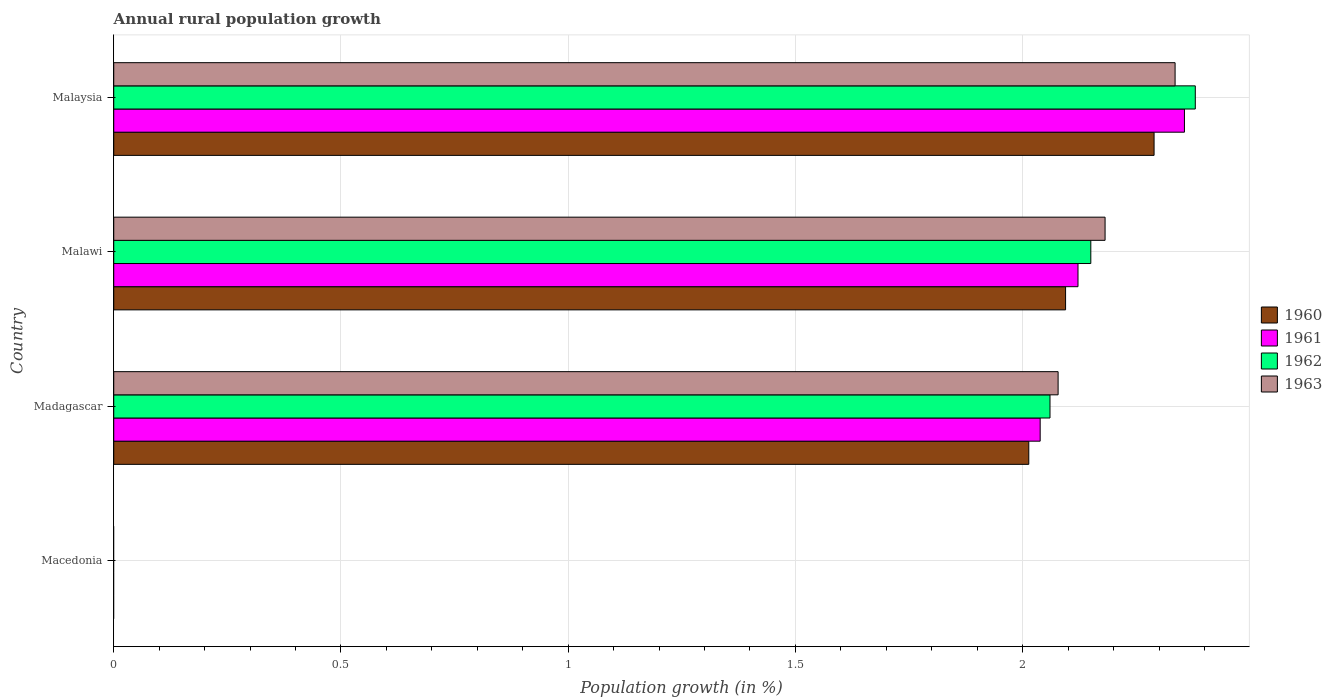How many different coloured bars are there?
Ensure brevity in your answer.  4. What is the label of the 4th group of bars from the top?
Make the answer very short. Macedonia. What is the percentage of rural population growth in 1961 in Malawi?
Your response must be concise. 2.12. Across all countries, what is the maximum percentage of rural population growth in 1960?
Offer a terse response. 2.29. Across all countries, what is the minimum percentage of rural population growth in 1962?
Your answer should be very brief. 0. In which country was the percentage of rural population growth in 1963 maximum?
Offer a very short reply. Malaysia. What is the total percentage of rural population growth in 1962 in the graph?
Keep it short and to the point. 6.59. What is the difference between the percentage of rural population growth in 1962 in Malawi and that in Malaysia?
Offer a very short reply. -0.23. What is the difference between the percentage of rural population growth in 1963 in Malaysia and the percentage of rural population growth in 1962 in Madagascar?
Your answer should be very brief. 0.28. What is the average percentage of rural population growth in 1960 per country?
Ensure brevity in your answer.  1.6. What is the difference between the percentage of rural population growth in 1961 and percentage of rural population growth in 1960 in Malawi?
Your response must be concise. 0.03. In how many countries, is the percentage of rural population growth in 1962 greater than 0.8 %?
Offer a terse response. 3. What is the ratio of the percentage of rural population growth in 1962 in Malawi to that in Malaysia?
Keep it short and to the point. 0.9. What is the difference between the highest and the second highest percentage of rural population growth in 1963?
Provide a short and direct response. 0.15. What is the difference between the highest and the lowest percentage of rural population growth in 1962?
Keep it short and to the point. 2.38. In how many countries, is the percentage of rural population growth in 1962 greater than the average percentage of rural population growth in 1962 taken over all countries?
Provide a succinct answer. 3. Is the sum of the percentage of rural population growth in 1961 in Malawi and Malaysia greater than the maximum percentage of rural population growth in 1963 across all countries?
Give a very brief answer. Yes. Is it the case that in every country, the sum of the percentage of rural population growth in 1961 and percentage of rural population growth in 1963 is greater than the sum of percentage of rural population growth in 1960 and percentage of rural population growth in 1962?
Offer a very short reply. No. Is it the case that in every country, the sum of the percentage of rural population growth in 1963 and percentage of rural population growth in 1961 is greater than the percentage of rural population growth in 1962?
Keep it short and to the point. No. How many bars are there?
Keep it short and to the point. 12. Are all the bars in the graph horizontal?
Provide a short and direct response. Yes. What is the difference between two consecutive major ticks on the X-axis?
Offer a terse response. 0.5. Where does the legend appear in the graph?
Give a very brief answer. Center right. How are the legend labels stacked?
Give a very brief answer. Vertical. What is the title of the graph?
Make the answer very short. Annual rural population growth. Does "1995" appear as one of the legend labels in the graph?
Ensure brevity in your answer.  No. What is the label or title of the X-axis?
Your answer should be very brief. Population growth (in %). What is the Population growth (in %) in 1960 in Macedonia?
Provide a short and direct response. 0. What is the Population growth (in %) of 1961 in Macedonia?
Ensure brevity in your answer.  0. What is the Population growth (in %) of 1963 in Macedonia?
Keep it short and to the point. 0. What is the Population growth (in %) in 1960 in Madagascar?
Make the answer very short. 2.01. What is the Population growth (in %) in 1961 in Madagascar?
Provide a succinct answer. 2.04. What is the Population growth (in %) in 1962 in Madagascar?
Offer a terse response. 2.06. What is the Population growth (in %) of 1963 in Madagascar?
Provide a succinct answer. 2.08. What is the Population growth (in %) of 1960 in Malawi?
Offer a terse response. 2.09. What is the Population growth (in %) of 1961 in Malawi?
Make the answer very short. 2.12. What is the Population growth (in %) of 1962 in Malawi?
Offer a very short reply. 2.15. What is the Population growth (in %) in 1963 in Malawi?
Provide a short and direct response. 2.18. What is the Population growth (in %) in 1960 in Malaysia?
Keep it short and to the point. 2.29. What is the Population growth (in %) in 1961 in Malaysia?
Ensure brevity in your answer.  2.36. What is the Population growth (in %) of 1962 in Malaysia?
Provide a short and direct response. 2.38. What is the Population growth (in %) in 1963 in Malaysia?
Offer a very short reply. 2.34. Across all countries, what is the maximum Population growth (in %) in 1960?
Provide a succinct answer. 2.29. Across all countries, what is the maximum Population growth (in %) in 1961?
Offer a terse response. 2.36. Across all countries, what is the maximum Population growth (in %) in 1962?
Provide a succinct answer. 2.38. Across all countries, what is the maximum Population growth (in %) of 1963?
Provide a succinct answer. 2.34. Across all countries, what is the minimum Population growth (in %) of 1962?
Your response must be concise. 0. What is the total Population growth (in %) in 1960 in the graph?
Your answer should be very brief. 6.4. What is the total Population growth (in %) of 1961 in the graph?
Provide a short and direct response. 6.52. What is the total Population growth (in %) in 1962 in the graph?
Make the answer very short. 6.59. What is the total Population growth (in %) in 1963 in the graph?
Provide a short and direct response. 6.59. What is the difference between the Population growth (in %) of 1960 in Madagascar and that in Malawi?
Give a very brief answer. -0.08. What is the difference between the Population growth (in %) in 1961 in Madagascar and that in Malawi?
Provide a succinct answer. -0.08. What is the difference between the Population growth (in %) of 1962 in Madagascar and that in Malawi?
Your answer should be very brief. -0.09. What is the difference between the Population growth (in %) in 1963 in Madagascar and that in Malawi?
Your answer should be compact. -0.1. What is the difference between the Population growth (in %) of 1960 in Madagascar and that in Malaysia?
Offer a terse response. -0.28. What is the difference between the Population growth (in %) in 1961 in Madagascar and that in Malaysia?
Ensure brevity in your answer.  -0.32. What is the difference between the Population growth (in %) of 1962 in Madagascar and that in Malaysia?
Provide a succinct answer. -0.32. What is the difference between the Population growth (in %) in 1963 in Madagascar and that in Malaysia?
Provide a succinct answer. -0.26. What is the difference between the Population growth (in %) in 1960 in Malawi and that in Malaysia?
Provide a succinct answer. -0.19. What is the difference between the Population growth (in %) of 1961 in Malawi and that in Malaysia?
Ensure brevity in your answer.  -0.23. What is the difference between the Population growth (in %) in 1962 in Malawi and that in Malaysia?
Provide a succinct answer. -0.23. What is the difference between the Population growth (in %) in 1963 in Malawi and that in Malaysia?
Provide a short and direct response. -0.15. What is the difference between the Population growth (in %) in 1960 in Madagascar and the Population growth (in %) in 1961 in Malawi?
Your answer should be very brief. -0.11. What is the difference between the Population growth (in %) in 1960 in Madagascar and the Population growth (in %) in 1962 in Malawi?
Your answer should be very brief. -0.14. What is the difference between the Population growth (in %) of 1960 in Madagascar and the Population growth (in %) of 1963 in Malawi?
Provide a succinct answer. -0.17. What is the difference between the Population growth (in %) of 1961 in Madagascar and the Population growth (in %) of 1962 in Malawi?
Your response must be concise. -0.11. What is the difference between the Population growth (in %) of 1961 in Madagascar and the Population growth (in %) of 1963 in Malawi?
Ensure brevity in your answer.  -0.14. What is the difference between the Population growth (in %) in 1962 in Madagascar and the Population growth (in %) in 1963 in Malawi?
Offer a terse response. -0.12. What is the difference between the Population growth (in %) in 1960 in Madagascar and the Population growth (in %) in 1961 in Malaysia?
Keep it short and to the point. -0.34. What is the difference between the Population growth (in %) in 1960 in Madagascar and the Population growth (in %) in 1962 in Malaysia?
Your response must be concise. -0.37. What is the difference between the Population growth (in %) in 1960 in Madagascar and the Population growth (in %) in 1963 in Malaysia?
Make the answer very short. -0.32. What is the difference between the Population growth (in %) of 1961 in Madagascar and the Population growth (in %) of 1962 in Malaysia?
Provide a short and direct response. -0.34. What is the difference between the Population growth (in %) of 1961 in Madagascar and the Population growth (in %) of 1963 in Malaysia?
Keep it short and to the point. -0.3. What is the difference between the Population growth (in %) of 1962 in Madagascar and the Population growth (in %) of 1963 in Malaysia?
Provide a succinct answer. -0.28. What is the difference between the Population growth (in %) of 1960 in Malawi and the Population growth (in %) of 1961 in Malaysia?
Ensure brevity in your answer.  -0.26. What is the difference between the Population growth (in %) in 1960 in Malawi and the Population growth (in %) in 1962 in Malaysia?
Provide a short and direct response. -0.29. What is the difference between the Population growth (in %) in 1960 in Malawi and the Population growth (in %) in 1963 in Malaysia?
Provide a short and direct response. -0.24. What is the difference between the Population growth (in %) of 1961 in Malawi and the Population growth (in %) of 1962 in Malaysia?
Offer a terse response. -0.26. What is the difference between the Population growth (in %) in 1961 in Malawi and the Population growth (in %) in 1963 in Malaysia?
Provide a succinct answer. -0.21. What is the difference between the Population growth (in %) of 1962 in Malawi and the Population growth (in %) of 1963 in Malaysia?
Offer a very short reply. -0.19. What is the average Population growth (in %) in 1960 per country?
Offer a very short reply. 1.6. What is the average Population growth (in %) in 1961 per country?
Ensure brevity in your answer.  1.63. What is the average Population growth (in %) of 1962 per country?
Offer a very short reply. 1.65. What is the average Population growth (in %) of 1963 per country?
Make the answer very short. 1.65. What is the difference between the Population growth (in %) of 1960 and Population growth (in %) of 1961 in Madagascar?
Your response must be concise. -0.03. What is the difference between the Population growth (in %) of 1960 and Population growth (in %) of 1962 in Madagascar?
Your answer should be compact. -0.05. What is the difference between the Population growth (in %) in 1960 and Population growth (in %) in 1963 in Madagascar?
Provide a short and direct response. -0.06. What is the difference between the Population growth (in %) in 1961 and Population growth (in %) in 1962 in Madagascar?
Ensure brevity in your answer.  -0.02. What is the difference between the Population growth (in %) of 1961 and Population growth (in %) of 1963 in Madagascar?
Make the answer very short. -0.04. What is the difference between the Population growth (in %) of 1962 and Population growth (in %) of 1963 in Madagascar?
Offer a very short reply. -0.02. What is the difference between the Population growth (in %) in 1960 and Population growth (in %) in 1961 in Malawi?
Keep it short and to the point. -0.03. What is the difference between the Population growth (in %) of 1960 and Population growth (in %) of 1962 in Malawi?
Ensure brevity in your answer.  -0.06. What is the difference between the Population growth (in %) in 1960 and Population growth (in %) in 1963 in Malawi?
Your response must be concise. -0.09. What is the difference between the Population growth (in %) in 1961 and Population growth (in %) in 1962 in Malawi?
Give a very brief answer. -0.03. What is the difference between the Population growth (in %) of 1961 and Population growth (in %) of 1963 in Malawi?
Your answer should be compact. -0.06. What is the difference between the Population growth (in %) of 1962 and Population growth (in %) of 1963 in Malawi?
Your answer should be compact. -0.03. What is the difference between the Population growth (in %) of 1960 and Population growth (in %) of 1961 in Malaysia?
Offer a terse response. -0.07. What is the difference between the Population growth (in %) of 1960 and Population growth (in %) of 1962 in Malaysia?
Make the answer very short. -0.09. What is the difference between the Population growth (in %) of 1960 and Population growth (in %) of 1963 in Malaysia?
Your answer should be very brief. -0.05. What is the difference between the Population growth (in %) of 1961 and Population growth (in %) of 1962 in Malaysia?
Keep it short and to the point. -0.02. What is the difference between the Population growth (in %) of 1961 and Population growth (in %) of 1963 in Malaysia?
Your response must be concise. 0.02. What is the difference between the Population growth (in %) of 1962 and Population growth (in %) of 1963 in Malaysia?
Your answer should be very brief. 0.04. What is the ratio of the Population growth (in %) in 1960 in Madagascar to that in Malawi?
Make the answer very short. 0.96. What is the ratio of the Population growth (in %) in 1961 in Madagascar to that in Malawi?
Provide a short and direct response. 0.96. What is the ratio of the Population growth (in %) of 1962 in Madagascar to that in Malawi?
Ensure brevity in your answer.  0.96. What is the ratio of the Population growth (in %) in 1963 in Madagascar to that in Malawi?
Provide a short and direct response. 0.95. What is the ratio of the Population growth (in %) in 1960 in Madagascar to that in Malaysia?
Keep it short and to the point. 0.88. What is the ratio of the Population growth (in %) of 1961 in Madagascar to that in Malaysia?
Keep it short and to the point. 0.87. What is the ratio of the Population growth (in %) of 1962 in Madagascar to that in Malaysia?
Offer a terse response. 0.87. What is the ratio of the Population growth (in %) of 1963 in Madagascar to that in Malaysia?
Ensure brevity in your answer.  0.89. What is the ratio of the Population growth (in %) in 1960 in Malawi to that in Malaysia?
Offer a very short reply. 0.91. What is the ratio of the Population growth (in %) of 1961 in Malawi to that in Malaysia?
Ensure brevity in your answer.  0.9. What is the ratio of the Population growth (in %) of 1962 in Malawi to that in Malaysia?
Ensure brevity in your answer.  0.9. What is the ratio of the Population growth (in %) in 1963 in Malawi to that in Malaysia?
Provide a short and direct response. 0.93. What is the difference between the highest and the second highest Population growth (in %) in 1960?
Your response must be concise. 0.19. What is the difference between the highest and the second highest Population growth (in %) in 1961?
Give a very brief answer. 0.23. What is the difference between the highest and the second highest Population growth (in %) in 1962?
Give a very brief answer. 0.23. What is the difference between the highest and the second highest Population growth (in %) in 1963?
Your response must be concise. 0.15. What is the difference between the highest and the lowest Population growth (in %) in 1960?
Provide a short and direct response. 2.29. What is the difference between the highest and the lowest Population growth (in %) of 1961?
Your answer should be compact. 2.36. What is the difference between the highest and the lowest Population growth (in %) in 1962?
Offer a very short reply. 2.38. What is the difference between the highest and the lowest Population growth (in %) of 1963?
Your answer should be compact. 2.34. 